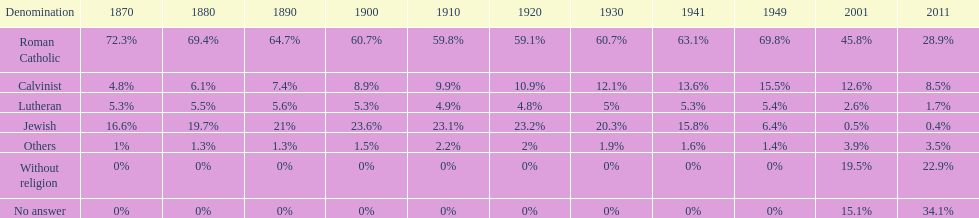What was the highest percentage of individuals identifying as calvinist? 15.5%. 